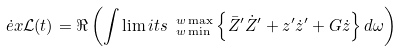<formula> <loc_0><loc_0><loc_500><loc_500>\dot { e } x \mathcal { L } ( t ) = \Re \left ( \int \lim i t s _ { \ w \min } ^ { \ w \max } \left \{ \bar { Z } ^ { \prime } \dot { Z } ^ { \prime } + z ^ { \prime } \dot { z } ^ { \prime } + G \dot { z } \right \} d \omega \right )</formula> 